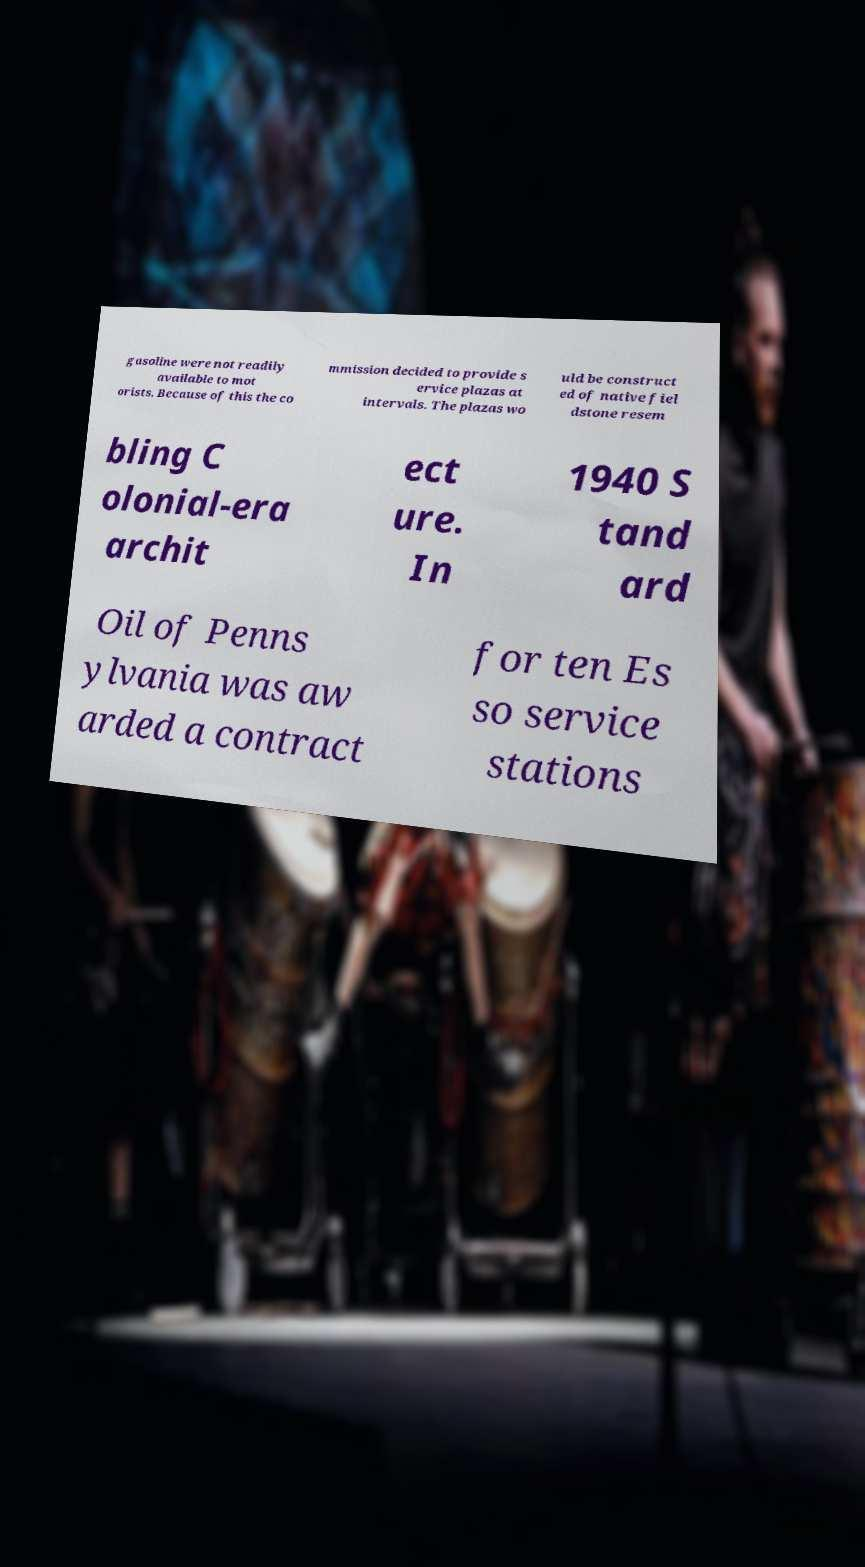What messages or text are displayed in this image? I need them in a readable, typed format. gasoline were not readily available to mot orists. Because of this the co mmission decided to provide s ervice plazas at intervals. The plazas wo uld be construct ed of native fiel dstone resem bling C olonial-era archit ect ure. In 1940 S tand ard Oil of Penns ylvania was aw arded a contract for ten Es so service stations 